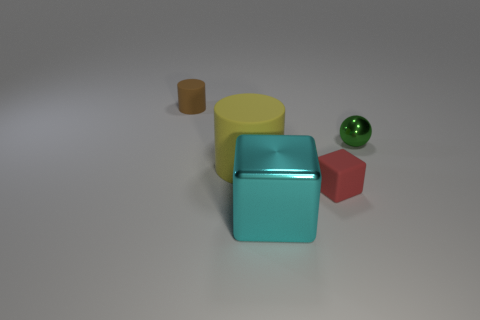What is the material of the object that is on the right side of the big rubber object and on the left side of the red matte block? The object situated to the right of the large rubber item and to the left of the red block appears to be made of metal, showcasing a reflective surface indicative of metallic materials. 